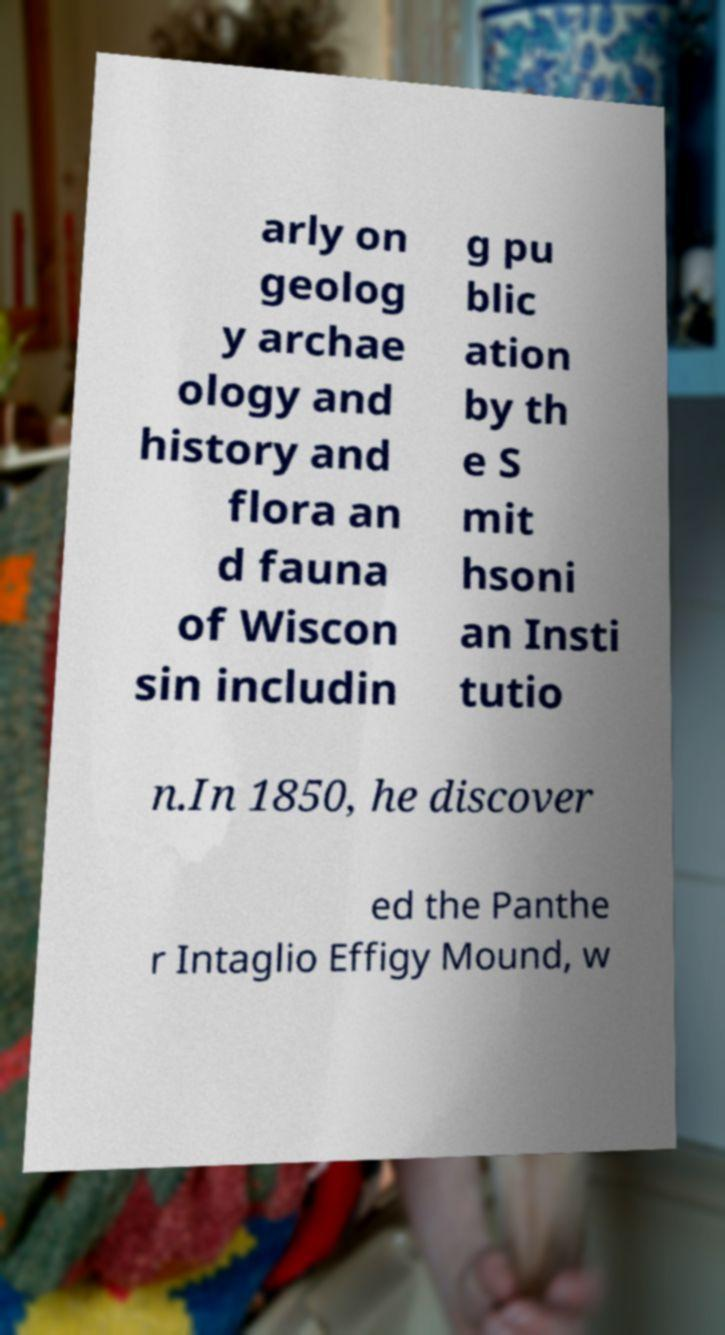There's text embedded in this image that I need extracted. Can you transcribe it verbatim? arly on geolog y archae ology and history and flora an d fauna of Wiscon sin includin g pu blic ation by th e S mit hsoni an Insti tutio n.In 1850, he discover ed the Panthe r Intaglio Effigy Mound, w 